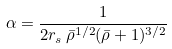<formula> <loc_0><loc_0><loc_500><loc_500>\alpha = \frac { 1 } { 2 r _ { s } \, \bar { \rho } ^ { 1 / 2 } ( \bar { \rho } + 1 ) ^ { 3 / 2 } }</formula> 